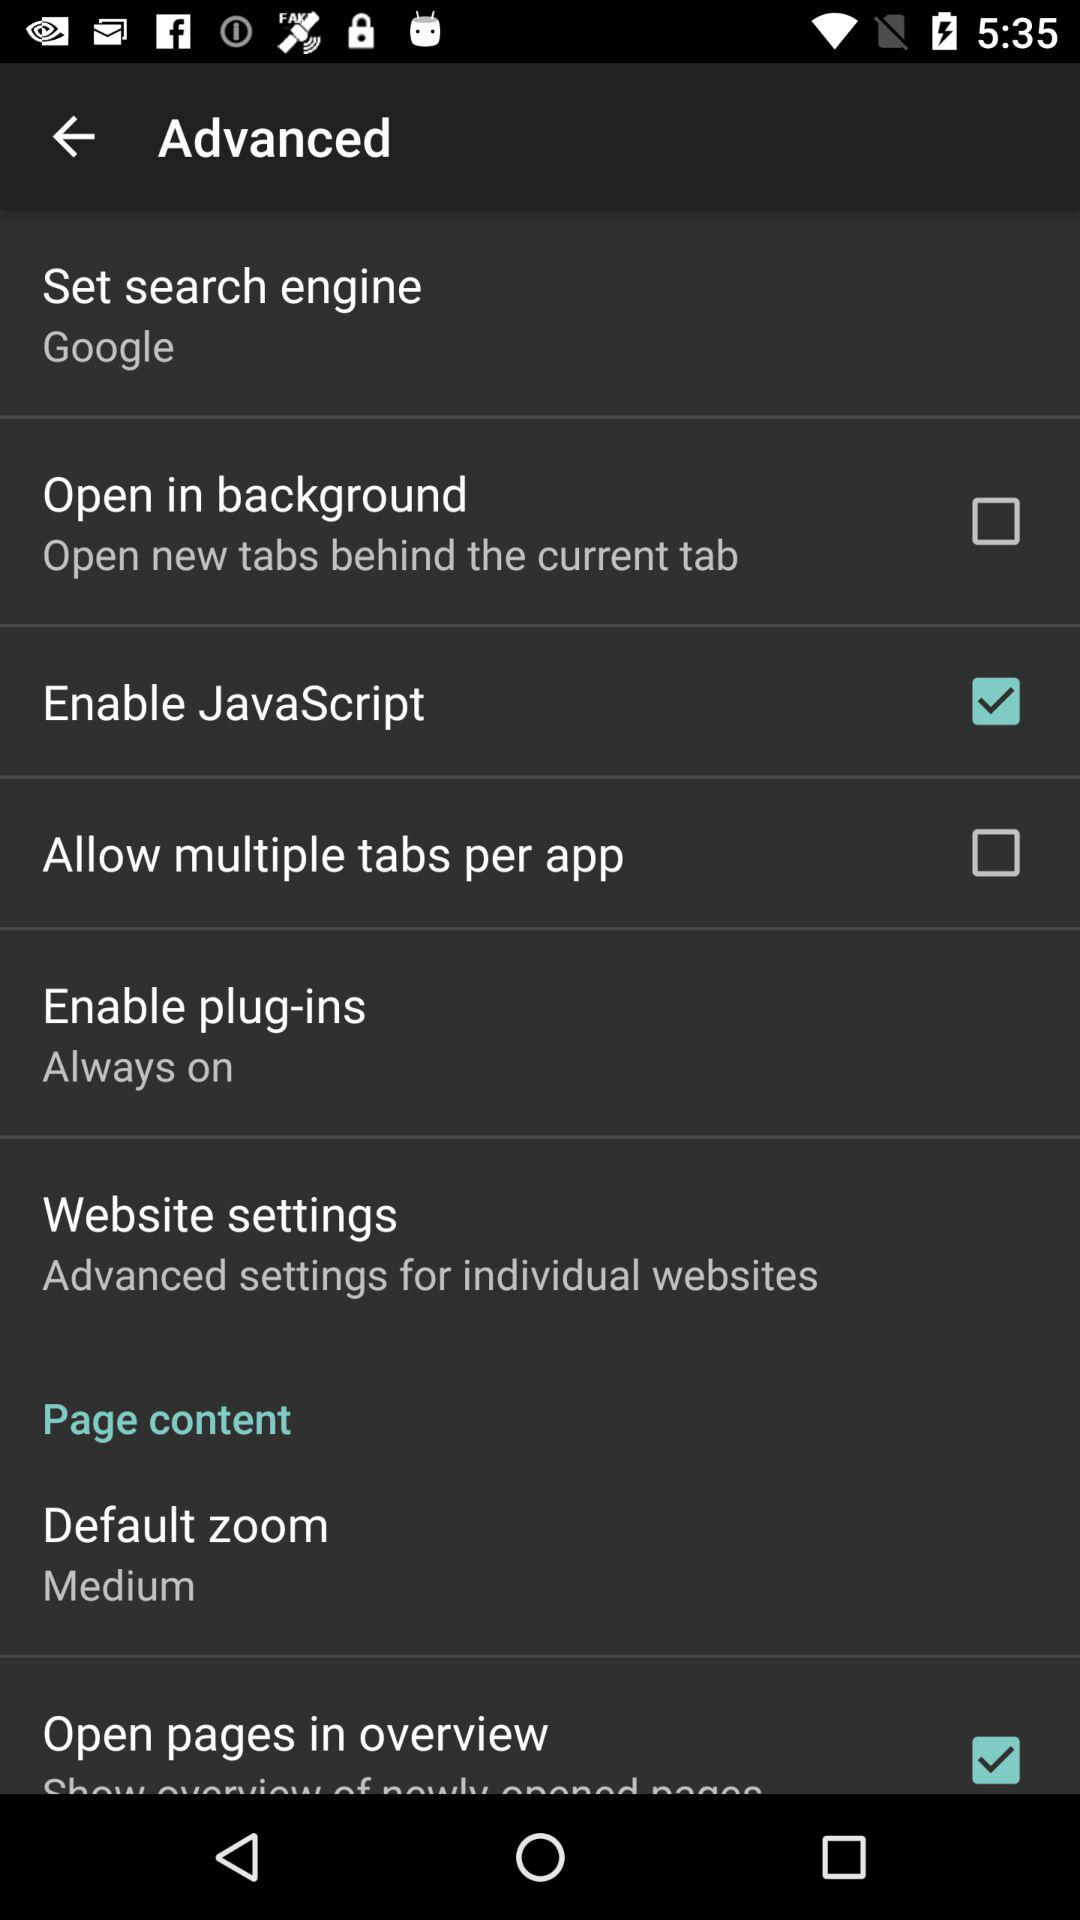What is the current status of "Open in background"? The current status of "Open in background" is "off". 